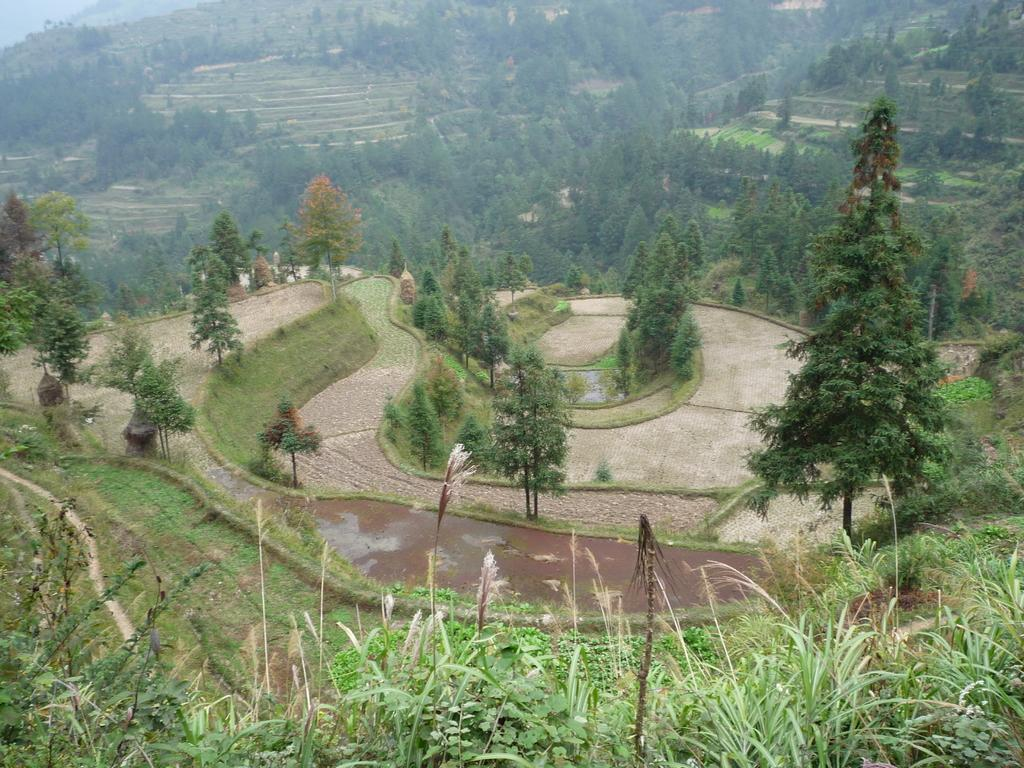What type of vegetation is present in the image? There are trees in the image. What type of ground cover is present in the image? There is grass in the image. What part of the natural environment is visible in the image? The sky is visible in the top left corner of the image. What type of net can be seen hanging from the trees in the image? There is no net present in the image; it only features trees, grass, and the sky. 